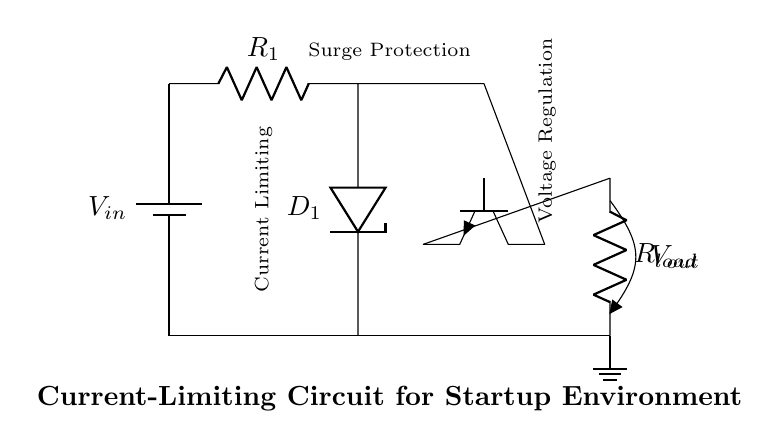What is the current-limiting component in the circuit? The current-limiting component is the resistor labeled R1. It is connected in series with the Zener diode and helps control the amount of current flowing through the circuit.
Answer: R1 What type of diode is used for surge protection? The Zener diode, labeled D1, is specifically used for voltage regulation and surge protection in this circuit. It clamps the voltage to a certain level to prevent overvoltage conditions.
Answer: Zener diode Where is the output voltage measured? The output voltage, labeled Vout, is measured across the load resistor Rload, which is located at the output of the circuit where the current flows to the load.
Answer: Rload What regulates the voltage in this circuit? The Zener diode D1 regulates the voltage by allowing reverse current flow when the voltage exceeds a certain threshold, thereby maintaining the output voltage within safe limits.
Answer: Zener diode What is the role of the transistor in this circuit? The transistor serves as a switch or amplifier that helps control the output voltage based on the input voltage and current conditions. It ensures that the load receives stable power while limiting current.
Answer: Transistor 